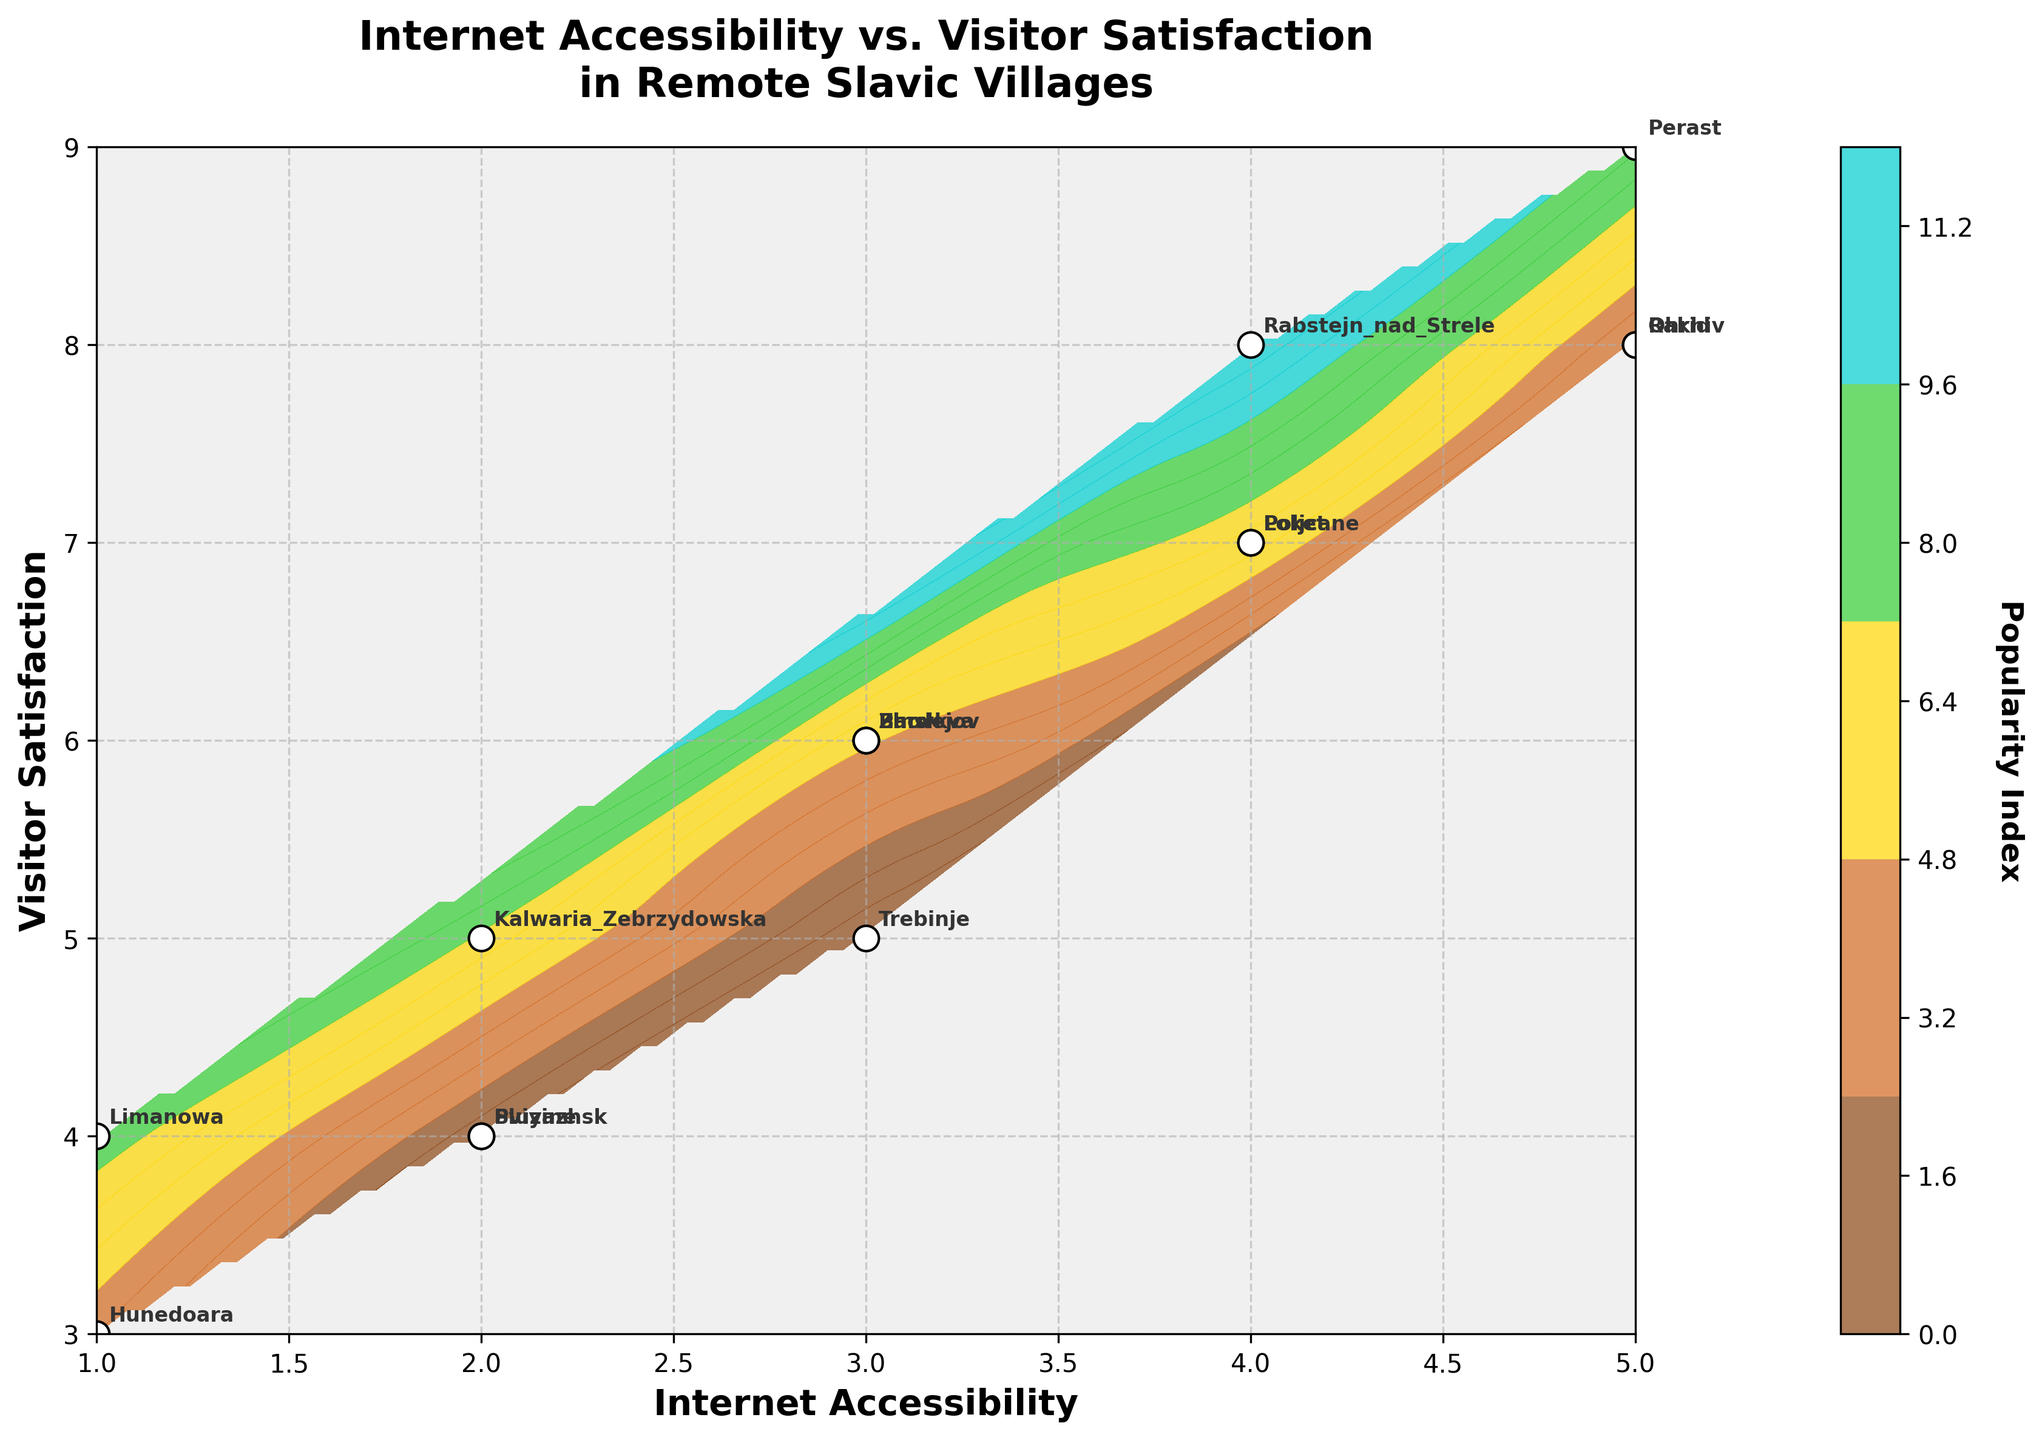What's the title of the figure? The title of the figure can be found at the top center. It reads: "Internet Accessibility vs. Visitor Satisfaction in Remote Slavic Villages"
Answer: "Internet Accessibility vs. Visitor Satisfaction in Remote Slavic Villages" Which location has the highest visitor satisfaction? The point with the highest visitor satisfaction is at the top right with a score of 9, which belongs to "Perast"
Answer: Perast What are the ranges for the x and y axes? The x-axis (Internet Accessibility) ranges from 1 to 5, and the y-axis (Visitor Satisfaction) ranges from 3 to 9, as indicated by the axis labels and the spread of data points.
Answer: Internet: 1-5, Visitor Satisfaction: 3-9 Which location has both the lowest Internet accessibility and visitor satisfaction? By looking at the data points at the lower-left corner of the plot, the location that has both the lowest Internet accessibility (1) and visitor satisfaction (3) is "Hunedoara"
Answer: Hunedoara What's the average visitor satisfaction for locations with an Internet accessibility level of 4? The locations with an Internet accessibility level of 4 are Poljcane, Loket, and Rabstejn nad Strele. Their visitor satisfaction levels are 7, 7, and 8, respectively. The average is calculated as (7 + 7 + 8) / 3 = 7.33
Answer: 7.33 Which location is represented by a data point at Internet accessibility 5 and visitor satisfaction 8? By matching the coordinates (5, 8) to the annotated points, the location is "Rakhiv"
Answer: Rakhiv Is there a general trend between Internet accessibility and visitor satisfaction in most locations? Looking at the scatter of data points and the contour lines, there seems to be a positive correlation; as Internet accessibility increases, visitor satisfaction tends to increase as well
Answer: Positive correlation How many locations are there in total on the plot? Counting all the annotated points on the scatter plot indicates that there are 15 locations
Answer: 15 Which color on the contour plot represents the highest popularity index, and where is it mostly concentrated? The color corresponding to the highest popularity index is cyan (teal color), and it is mostly concentrated in the upper right region of the plot where higher Internet accessibility and visitor satisfaction scores are found
Answer: Cyan, upper right What is the visitor satisfaction for Pinsk? By finding the label "Pinsk" on the plot, the data point indicates a visitor satisfaction of 6
Answer: 6 